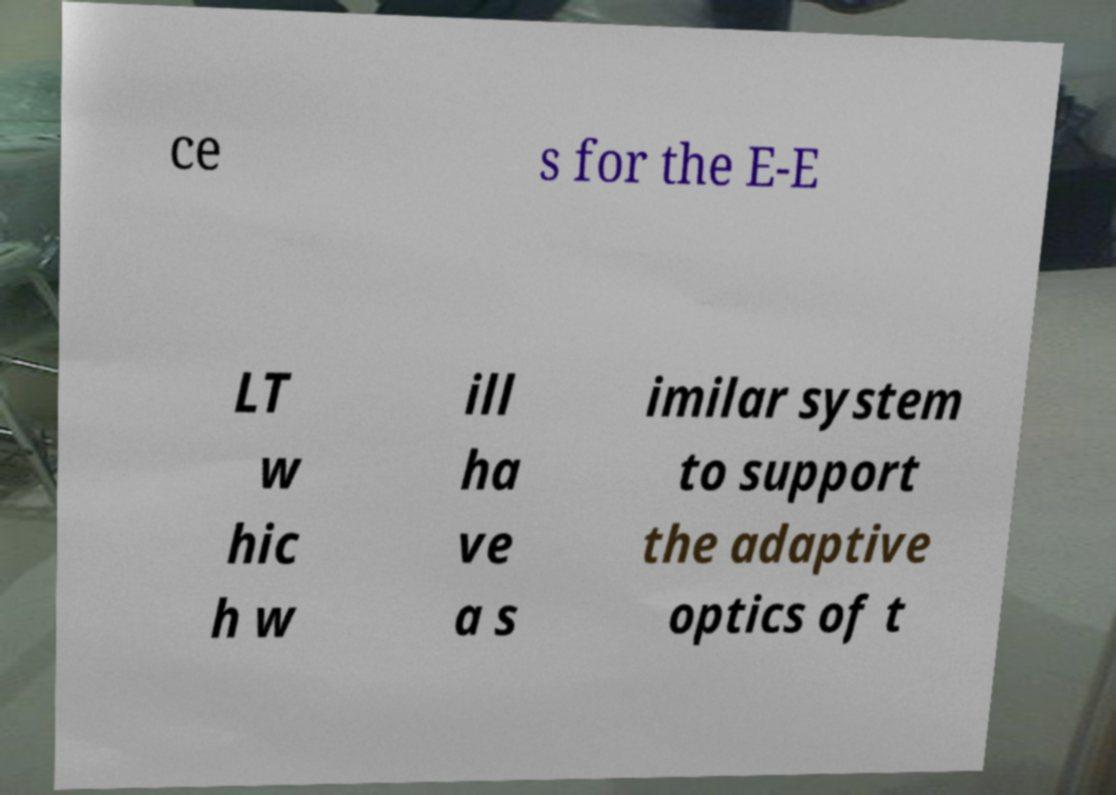Please identify and transcribe the text found in this image. ce s for the E-E LT w hic h w ill ha ve a s imilar system to support the adaptive optics of t 